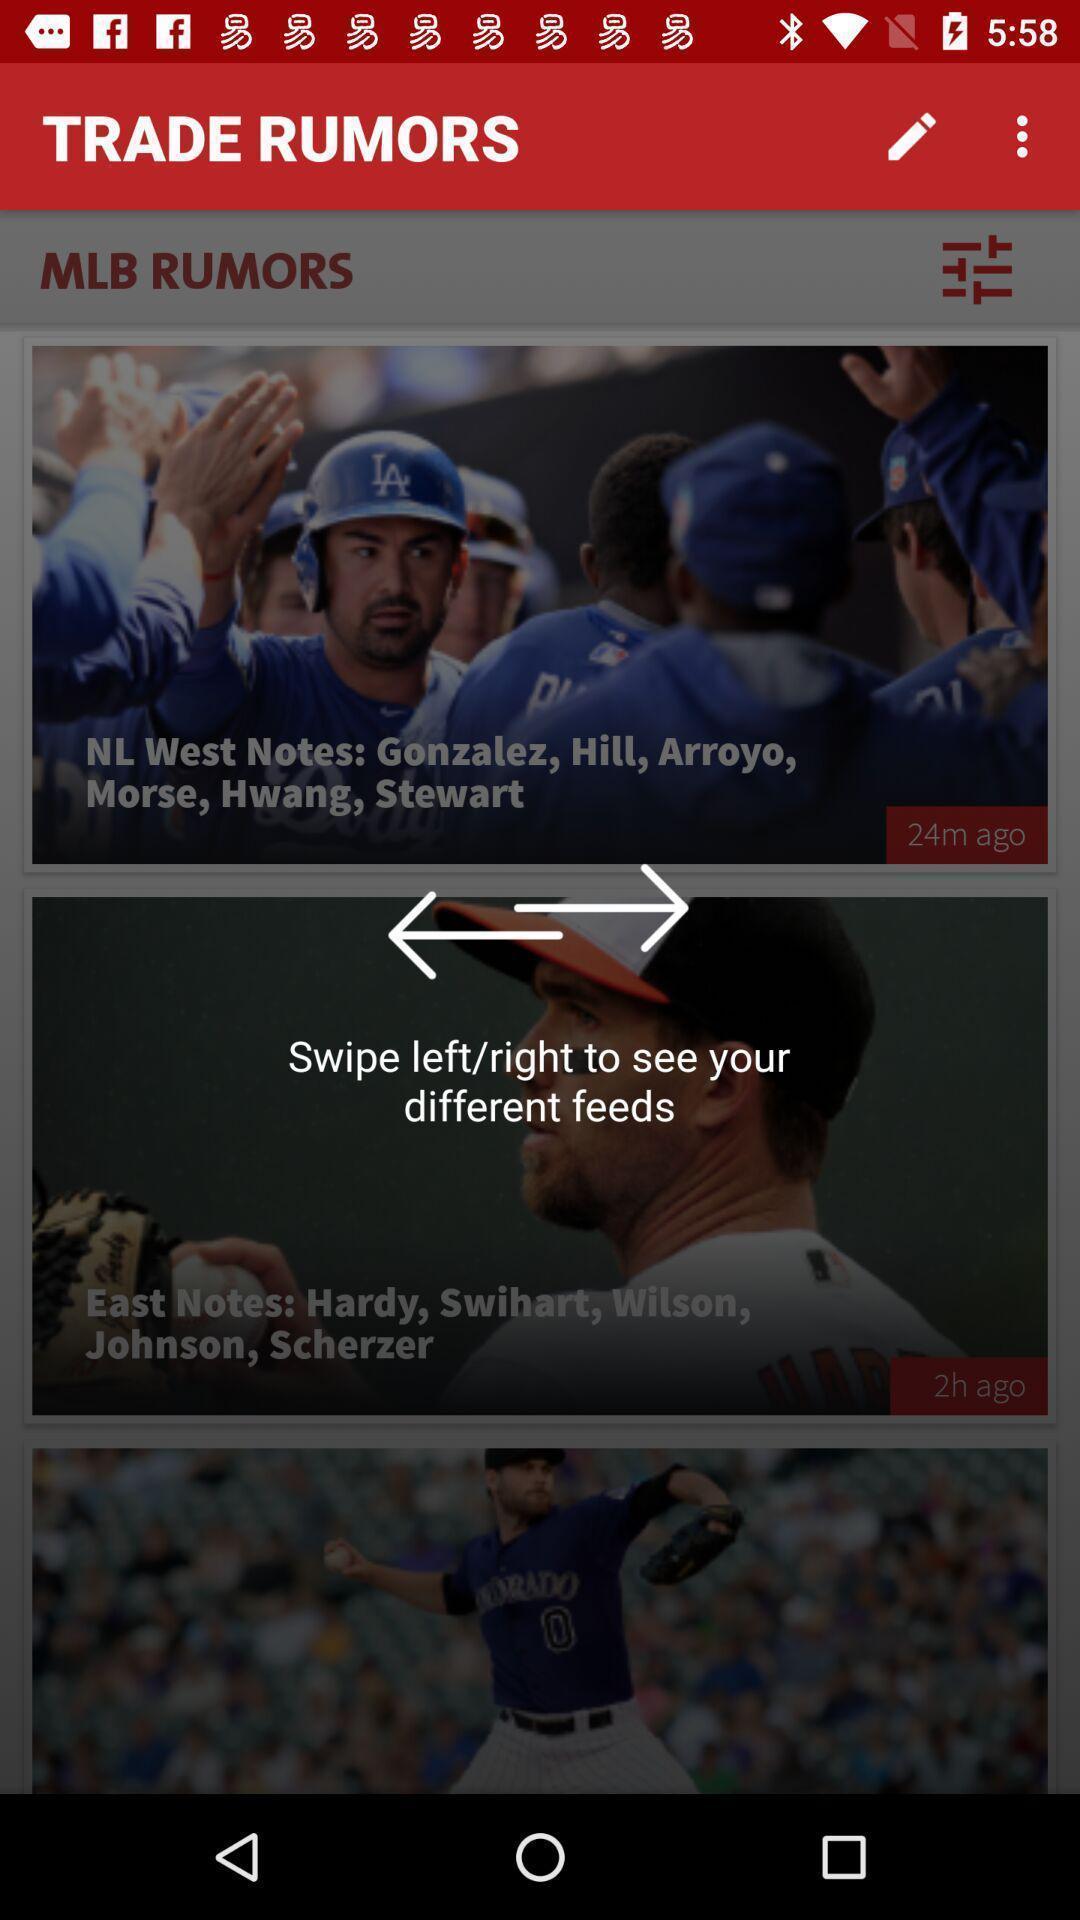Provide a description of this screenshot. Page showing information from trading app. 